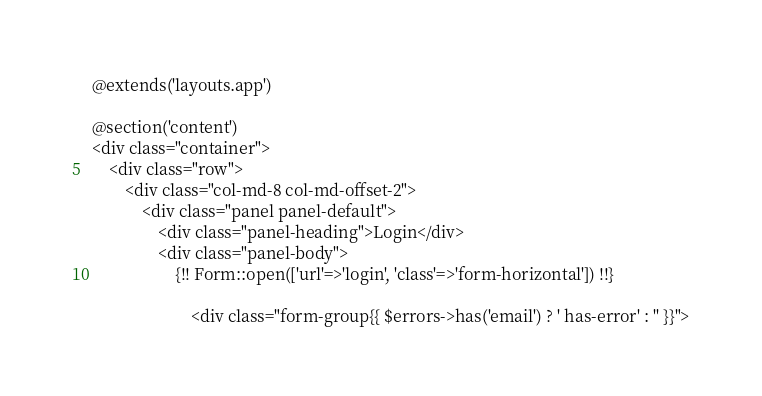<code> <loc_0><loc_0><loc_500><loc_500><_PHP_>@extends('layouts.app')

@section('content')
<div class="container">
    <div class="row">
        <div class="col-md-8 col-md-offset-2">
            <div class="panel panel-default">
                <div class="panel-heading">Login</div>
                <div class="panel-body">
                    {!! Form::open(['url'=>'login', 'class'=>'form-horizontal']) !!}

                        <div class="form-group{{ $errors->has('email') ? ' has-error' : '' }}"></code> 